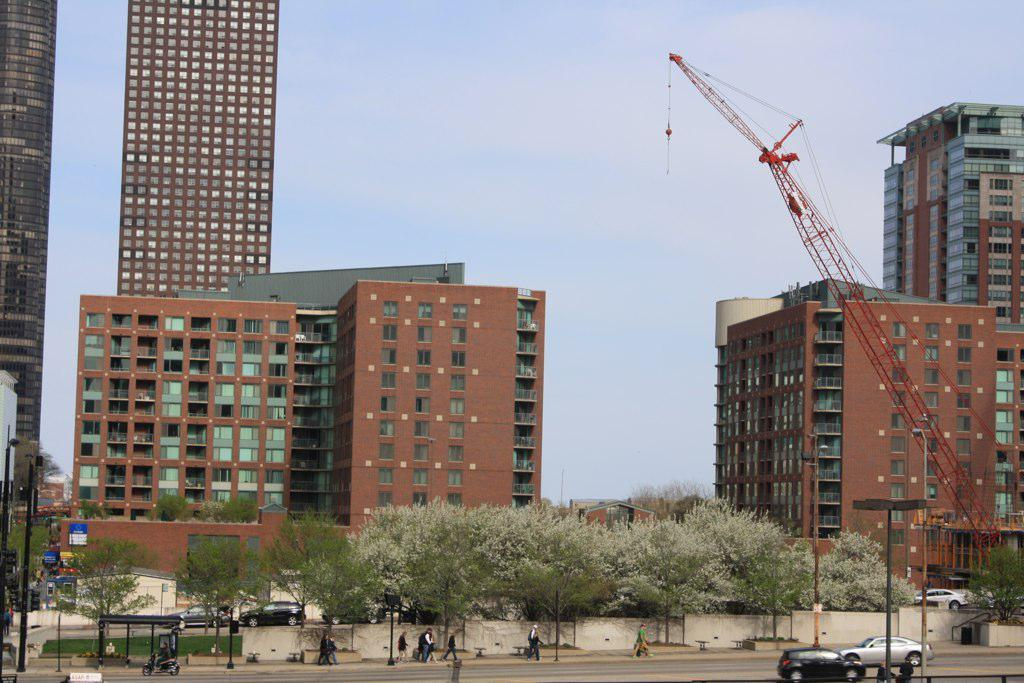What can be seen on the road in the image? There are vehicles and people on the road in the image. What else can be seen in the image besides the road? Trees, poles, buildings, and a window are visible in the image. What is the color of the sky in the image? The sky is blue in the image. How many knees are visible in the image? There is no mention of knees in the image, so it is impossible to determine how many are visible. What suggestions are being made by the passengers in the image? There is no indication of passengers or any suggestions being made in the image. 